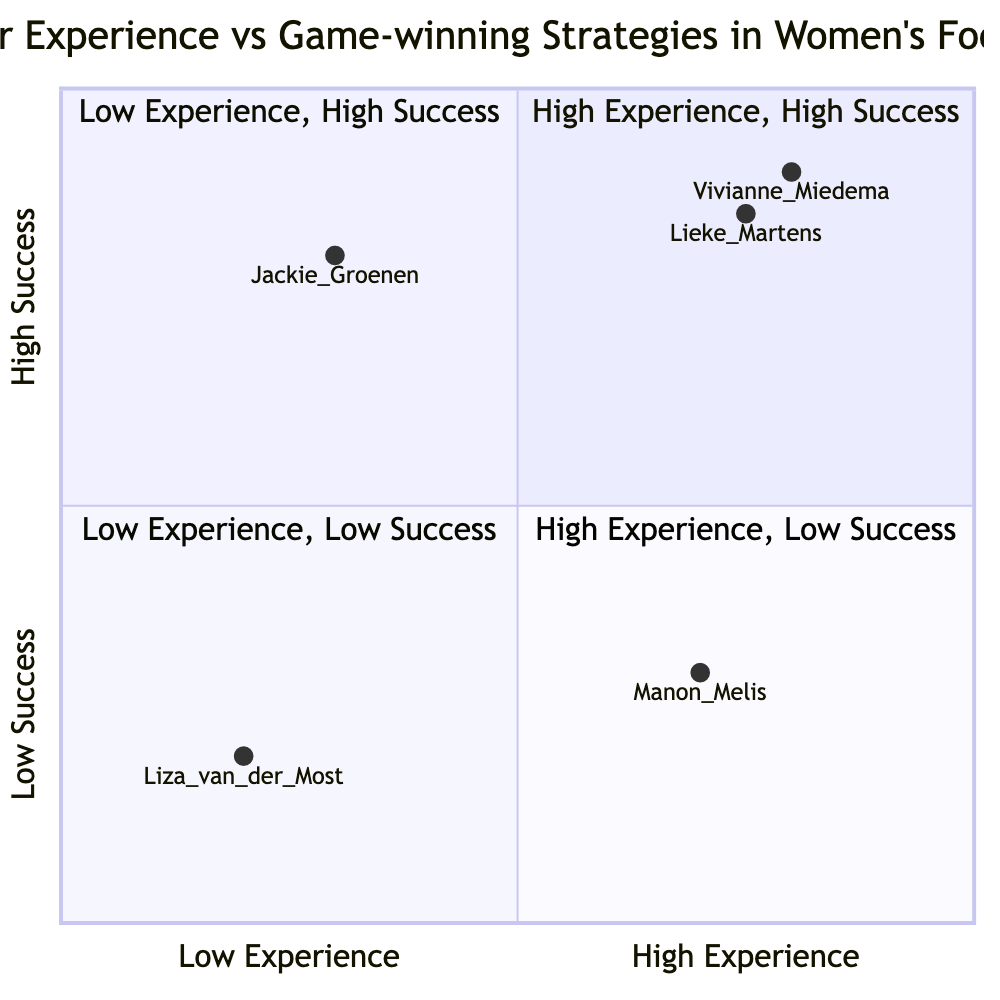What players are in the high experience, high success quadrant? The high experience, high success quadrant includes players with both high experience and high success metrics. Referring to the data, we have Vivianne Miedema and Lieke Martens in this quadrant.
Answer: Vivianne Miedema, Lieke Martens How many players are in the low experience, low success quadrant? The low experience, low success quadrant contains players who both have low experience and low success metrics. According to the data, there is one player, Liza van der Most, in this quadrant.
Answer: 1 Which player has the highest success among those with low experience? The question asks for the player within the low experience category that also has the highest success metric. Reviewing the data, Jackie Groenen, with a high success metric (0.8), is the only player in that quadrant that stands out.
Answer: Jackie Groenen What is the principal strategy of Manon Melis? This question seeks the specific strategy employed by Manon Melis, who is positioned in the high experience, low success quadrant. According to the data, her strategy is listed as Counter-Attacks.
Answer: Counter-Attacks How many players fall under the high experience, low success quadrant? To determine this, we need to count the players associated with the high experience, low success quadrant. From the data, there is one player, Manon Melis, positioned in this quadrant.
Answer: 1 